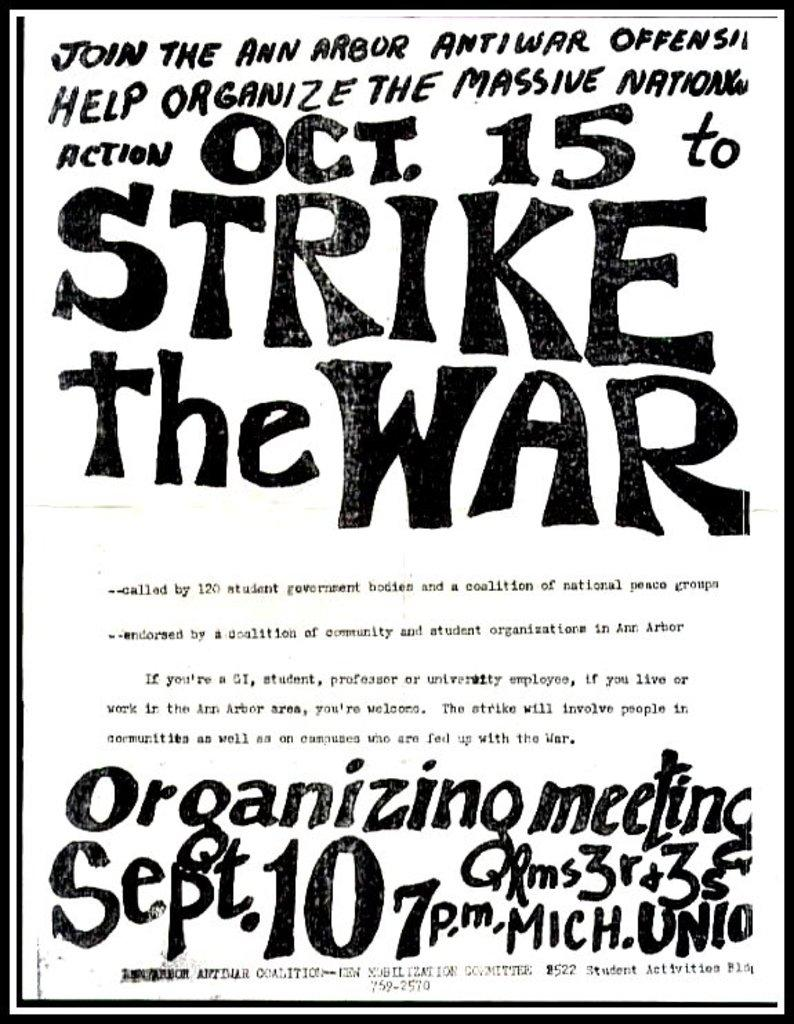<image>
Provide a brief description of the given image. Vintage text poster in black and white for Strike the War meeting held September 10th at 7 p.m. 